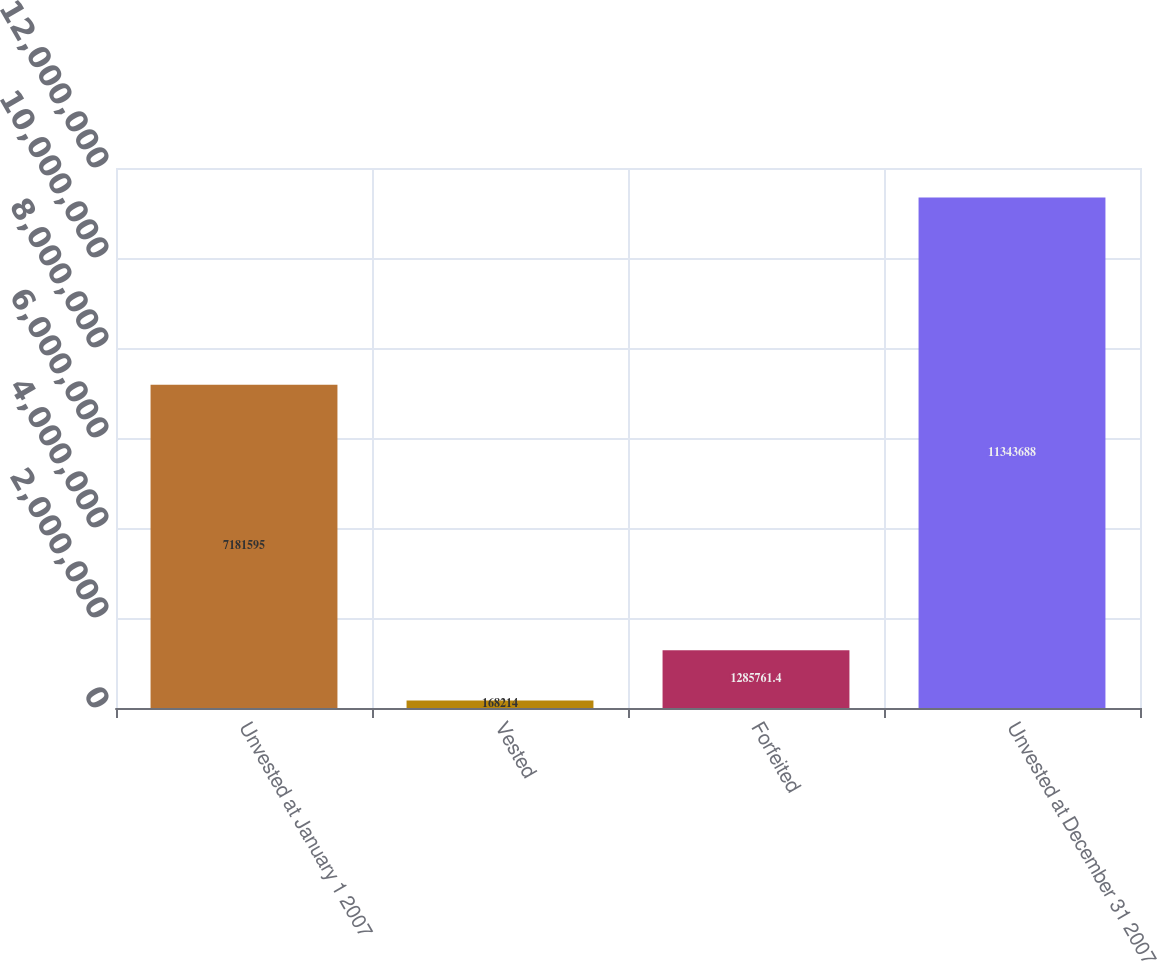Convert chart to OTSL. <chart><loc_0><loc_0><loc_500><loc_500><bar_chart><fcel>Unvested at January 1 2007<fcel>Vested<fcel>Forfeited<fcel>Unvested at December 31 2007<nl><fcel>7.1816e+06<fcel>168214<fcel>1.28576e+06<fcel>1.13437e+07<nl></chart> 